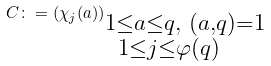Convert formula to latex. <formula><loc_0><loc_0><loc_500><loc_500>C \colon = \left ( \chi _ { j } ( a ) \right ) _ { \substack { 1 \leq a \leq q , \ ( a , q ) = 1 \\ 1 \leq j \leq \varphi ( q ) \quad } }</formula> 